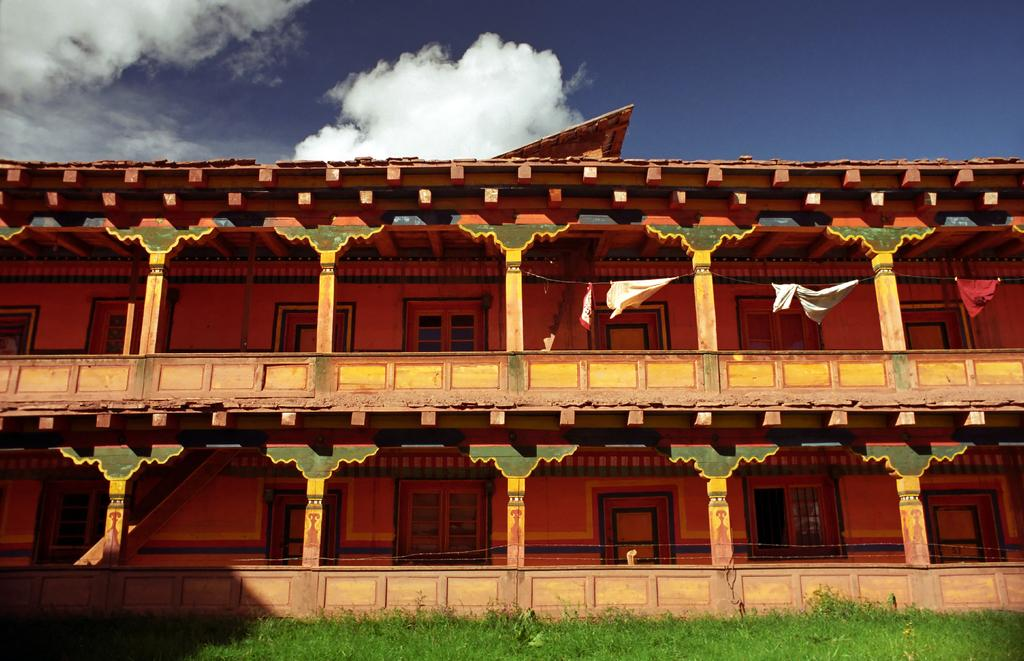What is the main structure in the image? There is a building in the center of the image. What can be seen above the building in the image? The sky is visible at the top of the image. What is present in the sky? Clouds are present in the sky. What is present at the bottom of the image? Grass is present at the bottom of the image. What type of receipt can be seen in the image? There is no receipt present in the image. 